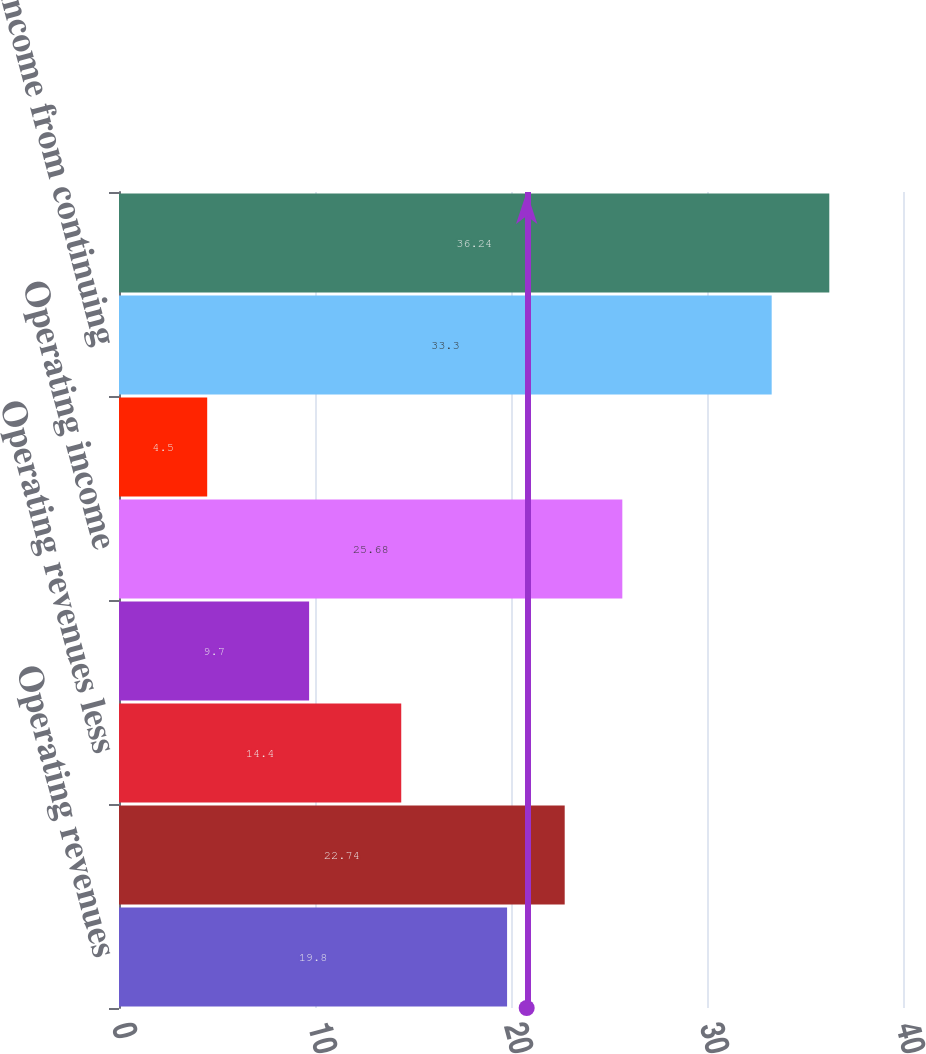<chart> <loc_0><loc_0><loc_500><loc_500><bar_chart><fcel>Operating revenues<fcel>Purchased power<fcel>Operating revenues less<fcel>Taxes other than income taxes<fcel>Operating income<fcel>Net interest charges<fcel>Income from continuing<fcel>Net income<nl><fcel>19.8<fcel>22.74<fcel>14.4<fcel>9.7<fcel>25.68<fcel>4.5<fcel>33.3<fcel>36.24<nl></chart> 